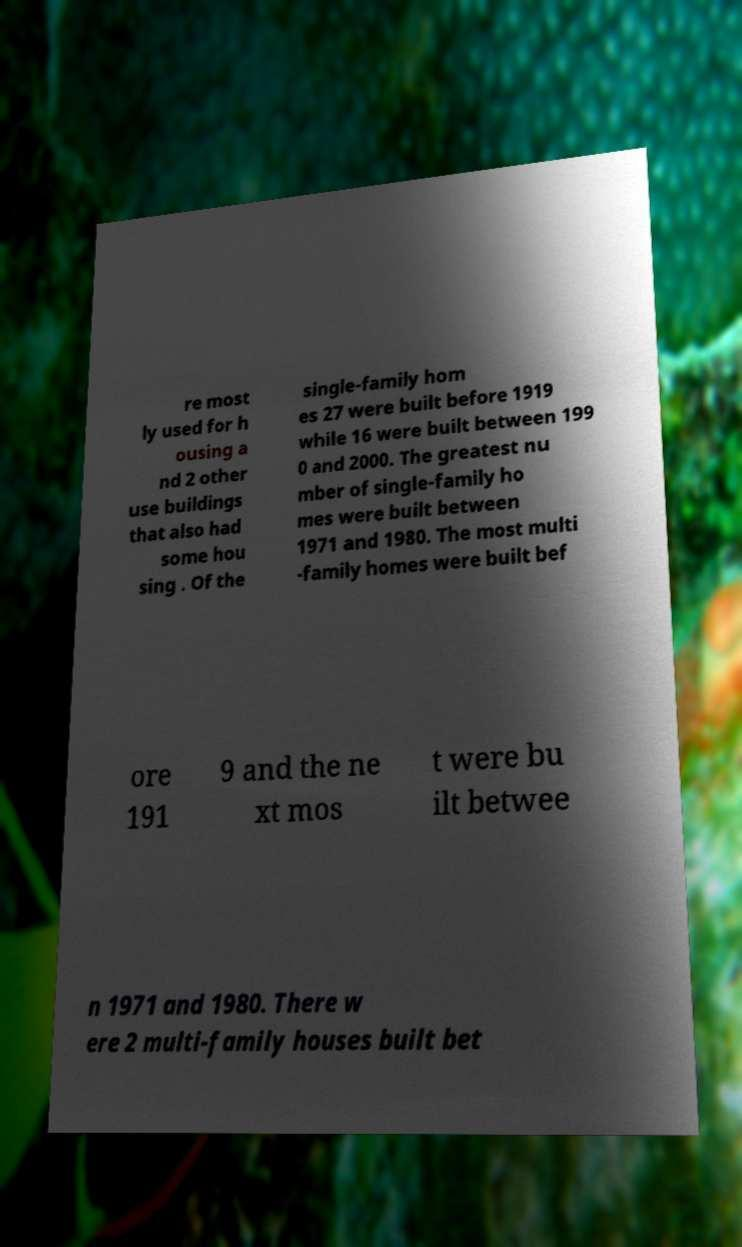I need the written content from this picture converted into text. Can you do that? re most ly used for h ousing a nd 2 other use buildings that also had some hou sing . Of the single-family hom es 27 were built before 1919 while 16 were built between 199 0 and 2000. The greatest nu mber of single-family ho mes were built between 1971 and 1980. The most multi -family homes were built bef ore 191 9 and the ne xt mos t were bu ilt betwee n 1971 and 1980. There w ere 2 multi-family houses built bet 